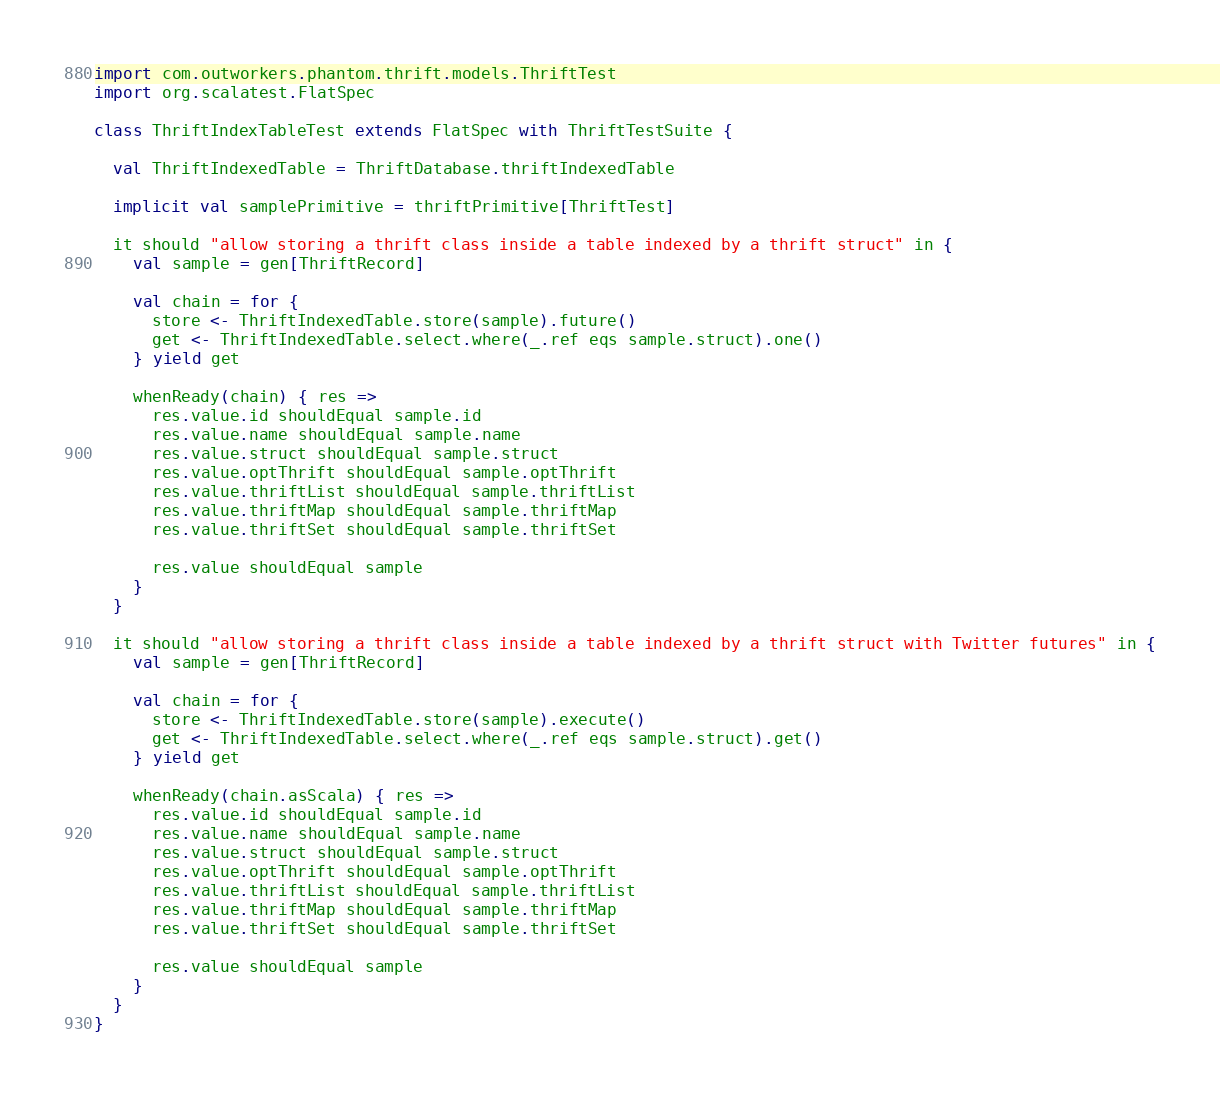Convert code to text. <code><loc_0><loc_0><loc_500><loc_500><_Scala_>import com.outworkers.phantom.thrift.models.ThriftTest
import org.scalatest.FlatSpec

class ThriftIndexTableTest extends FlatSpec with ThriftTestSuite {

  val ThriftIndexedTable = ThriftDatabase.thriftIndexedTable

  implicit val samplePrimitive = thriftPrimitive[ThriftTest]

  it should "allow storing a thrift class inside a table indexed by a thrift struct" in {
    val sample = gen[ThriftRecord]

    val chain = for {
      store <- ThriftIndexedTable.store(sample).future()
      get <- ThriftIndexedTable.select.where(_.ref eqs sample.struct).one()
    } yield get

    whenReady(chain) { res =>
      res.value.id shouldEqual sample.id
      res.value.name shouldEqual sample.name
      res.value.struct shouldEqual sample.struct
      res.value.optThrift shouldEqual sample.optThrift
      res.value.thriftList shouldEqual sample.thriftList
      res.value.thriftMap shouldEqual sample.thriftMap
      res.value.thriftSet shouldEqual sample.thriftSet

      res.value shouldEqual sample
    }
  }

  it should "allow storing a thrift class inside a table indexed by a thrift struct with Twitter futures" in {
    val sample = gen[ThriftRecord]

    val chain = for {
      store <- ThriftIndexedTable.store(sample).execute()
      get <- ThriftIndexedTable.select.where(_.ref eqs sample.struct).get()
    } yield get

    whenReady(chain.asScala) { res =>
      res.value.id shouldEqual sample.id
      res.value.name shouldEqual sample.name
      res.value.struct shouldEqual sample.struct
      res.value.optThrift shouldEqual sample.optThrift
      res.value.thriftList shouldEqual sample.thriftList
      res.value.thriftMap shouldEqual sample.thriftMap
      res.value.thriftSet shouldEqual sample.thriftSet

      res.value shouldEqual sample
    }
  }
}
</code> 